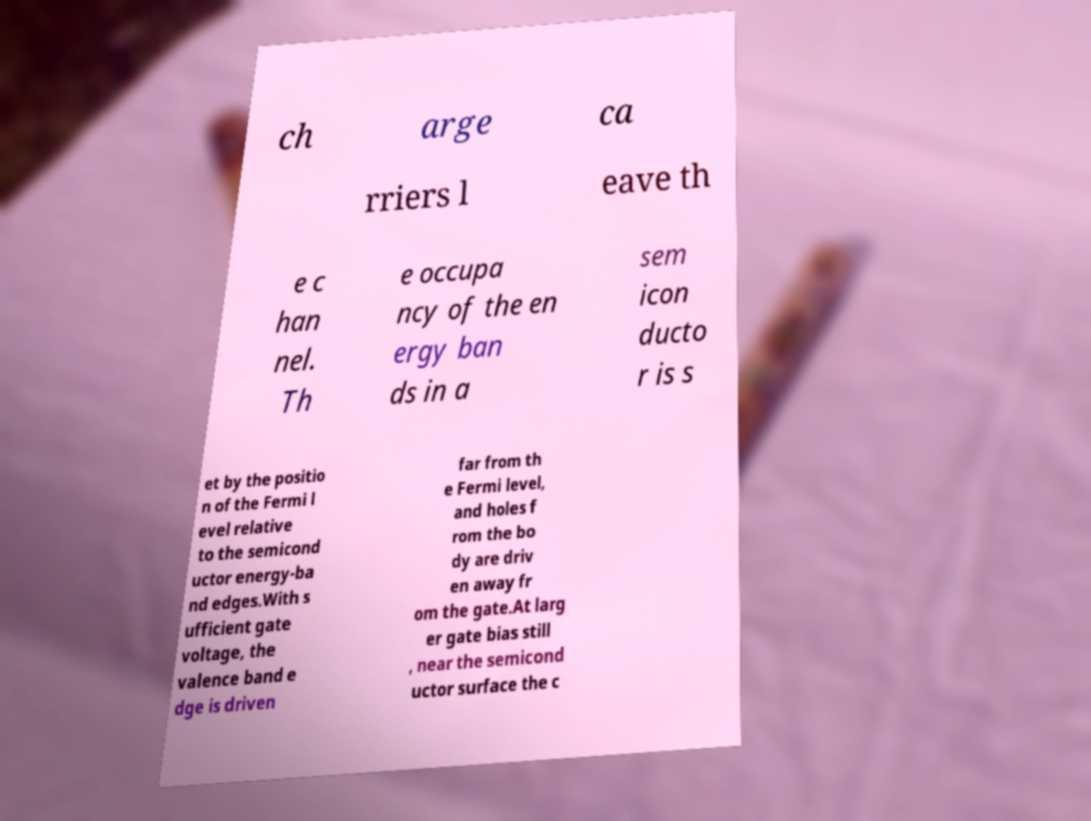Please identify and transcribe the text found in this image. ch arge ca rriers l eave th e c han nel. Th e occupa ncy of the en ergy ban ds in a sem icon ducto r is s et by the positio n of the Fermi l evel relative to the semicond uctor energy-ba nd edges.With s ufficient gate voltage, the valence band e dge is driven far from th e Fermi level, and holes f rom the bo dy are driv en away fr om the gate.At larg er gate bias still , near the semicond uctor surface the c 